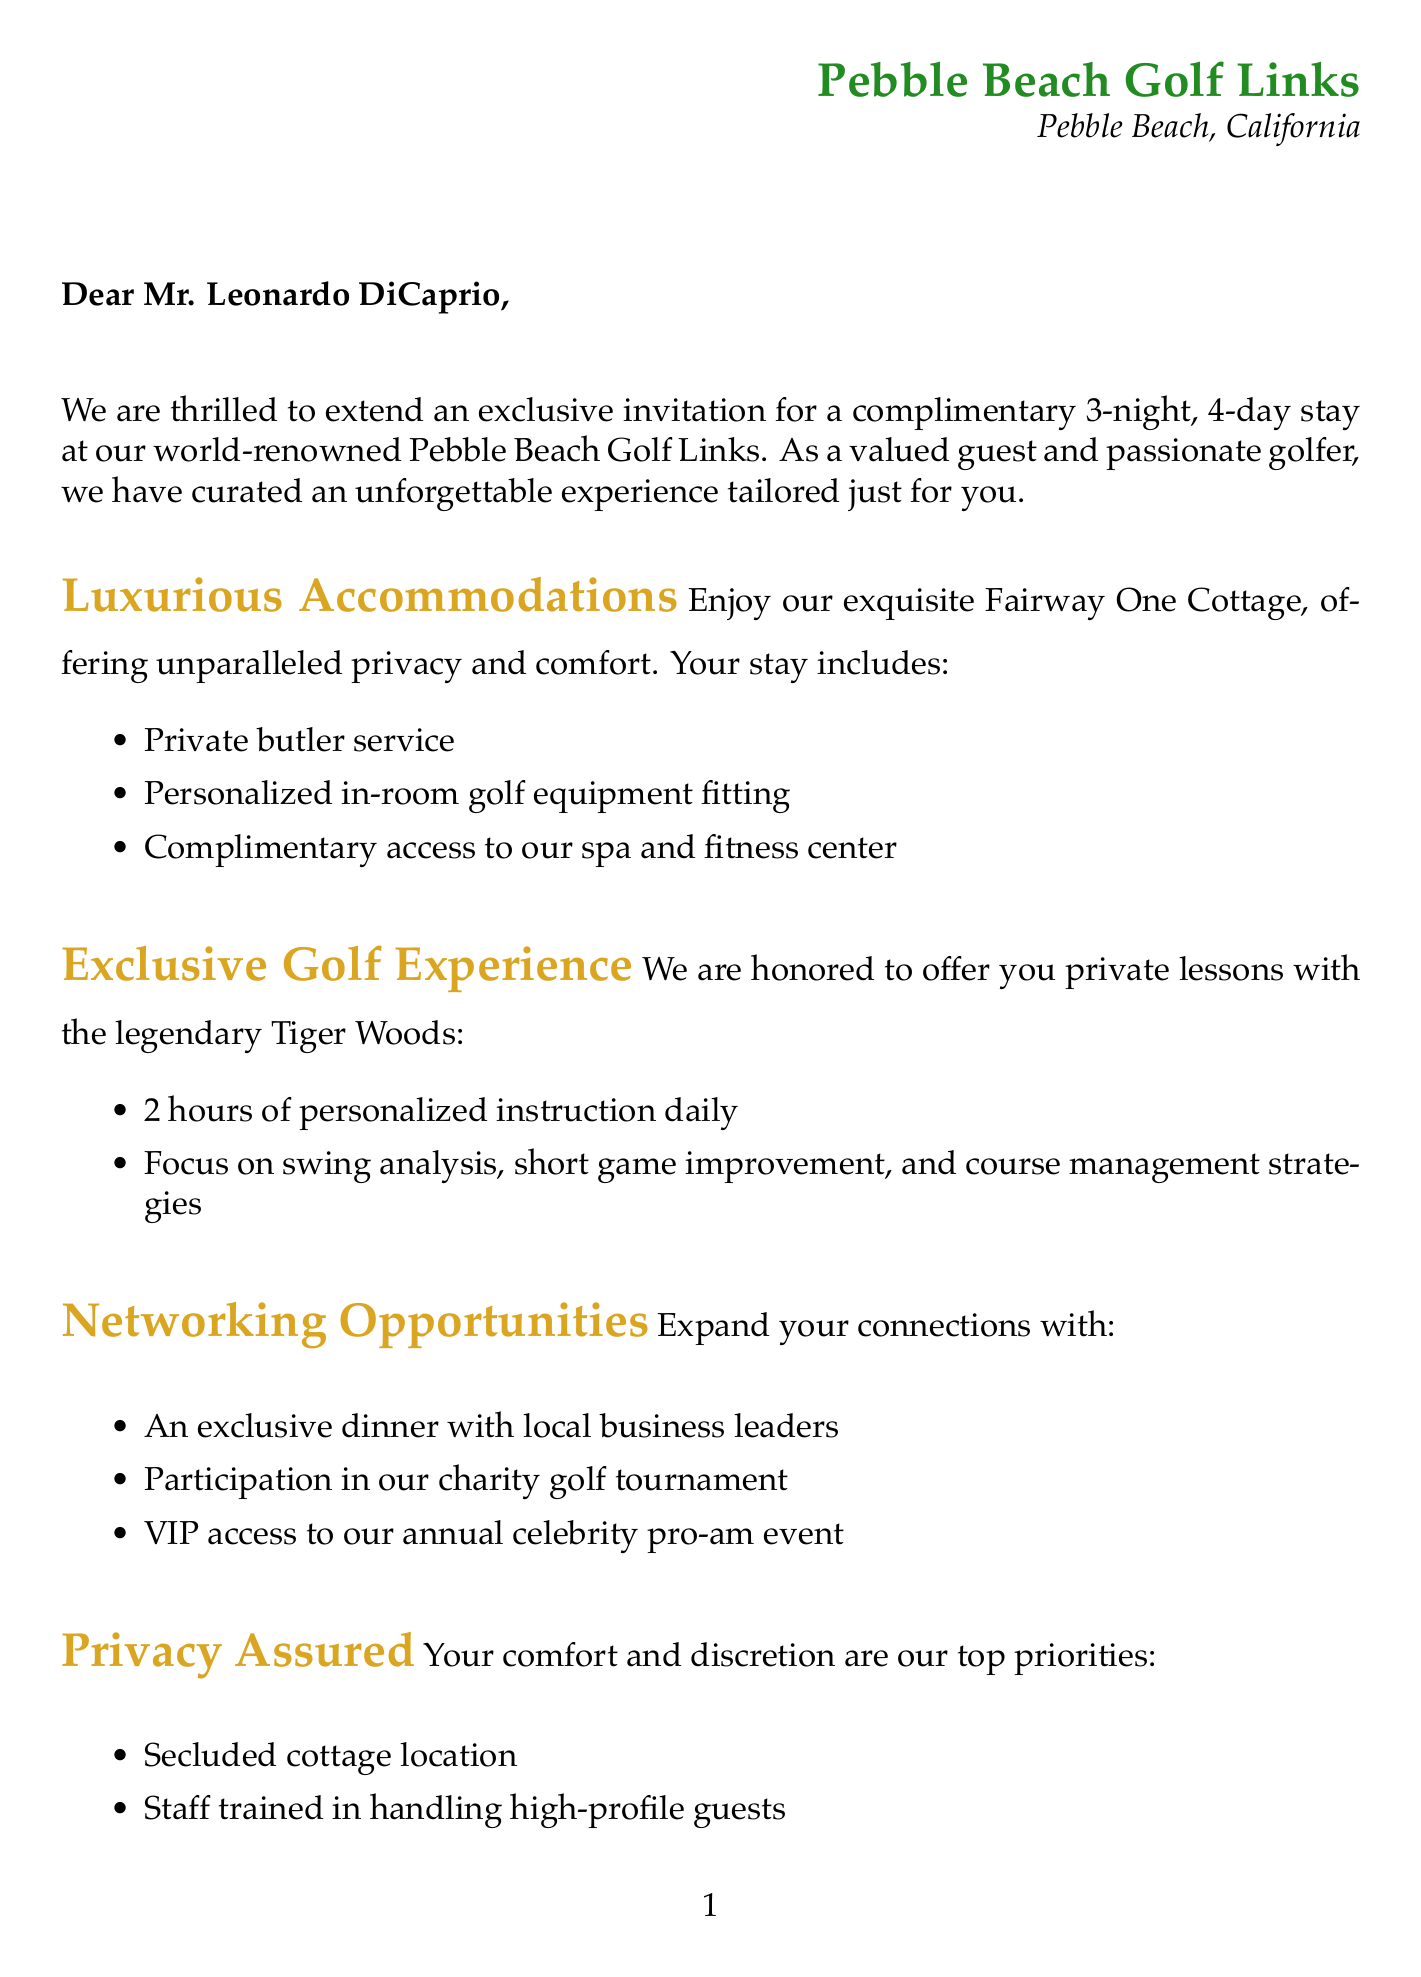What is the name of the resort? The resort is identified as Pebble Beach Golf Links in the document.
Answer: Pebble Beach Golf Links Who will provide the private lessons? The document mentions that Tiger Woods will be providing the private lessons.
Answer: Tiger Woods How many nights is the complimentary stay? The document specifies that the complimentary stay is for 3 nights.
Answer: 3 nights What is included in the exclusive golf experience? The exclusive golf experience includes 2 hours of personalized instruction daily, focusing on various aspects of golf.
Answer: 2 hours of personalized instruction daily What are the types of sustainability initiatives mentioned? The document lists ocean conservation partnership, use of electric golf carts, and locally-sourced organic menu options as sustainability initiatives.
Answer: Ocean conservation partnership, electric golf carts, organic menu options What is the contact person's title? The document states that the contact person's title is the VIP Guest Relations Manager.
Answer: VIP Guest Relations Manager What type of accommodation is offered? The document specifies that guests will stay in a Fairway One Cottage.
Answer: Fairway One Cottage What is the duration of the golf lessons? The duration of the golf lessons is mentioned as 2 hours per day.
Answer: 2 hours per day What extra amenities are provided during the stay? The document describes private butler service, personalized in-room fitting, and spa access as extra amenities.
Answer: Private butler service, fitting, spa access 